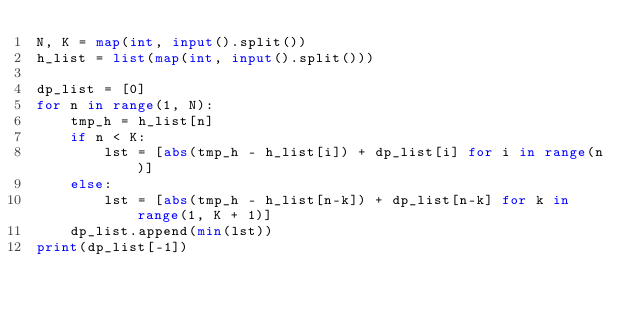Convert code to text. <code><loc_0><loc_0><loc_500><loc_500><_Python_>N, K = map(int, input().split())
h_list = list(map(int, input().split()))

dp_list = [0]
for n in range(1, N):
    tmp_h = h_list[n]
    if n < K:
        lst = [abs(tmp_h - h_list[i]) + dp_list[i] for i in range(n)]
    else:
        lst = [abs(tmp_h - h_list[n-k]) + dp_list[n-k] for k in range(1, K + 1)]
    dp_list.append(min(lst))
print(dp_list[-1])</code> 